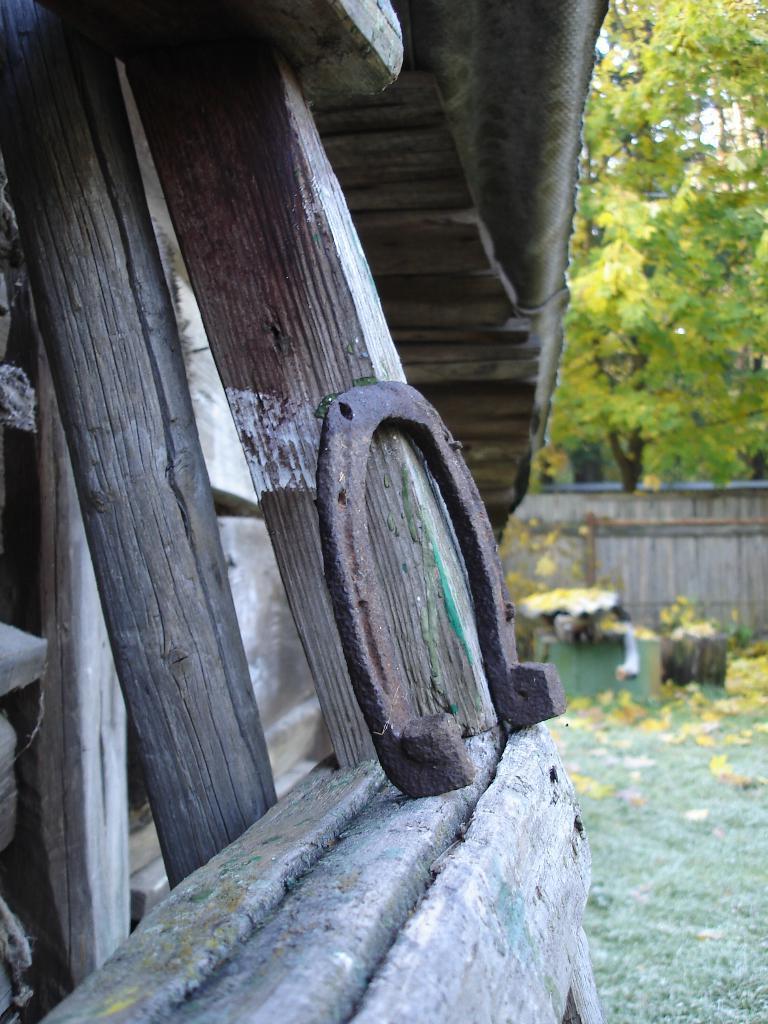Could you give a brief overview of what you see in this image? In this image I can see I can see trees, fence and other objects on the ground. Here I can see wooden poles and metal object. 